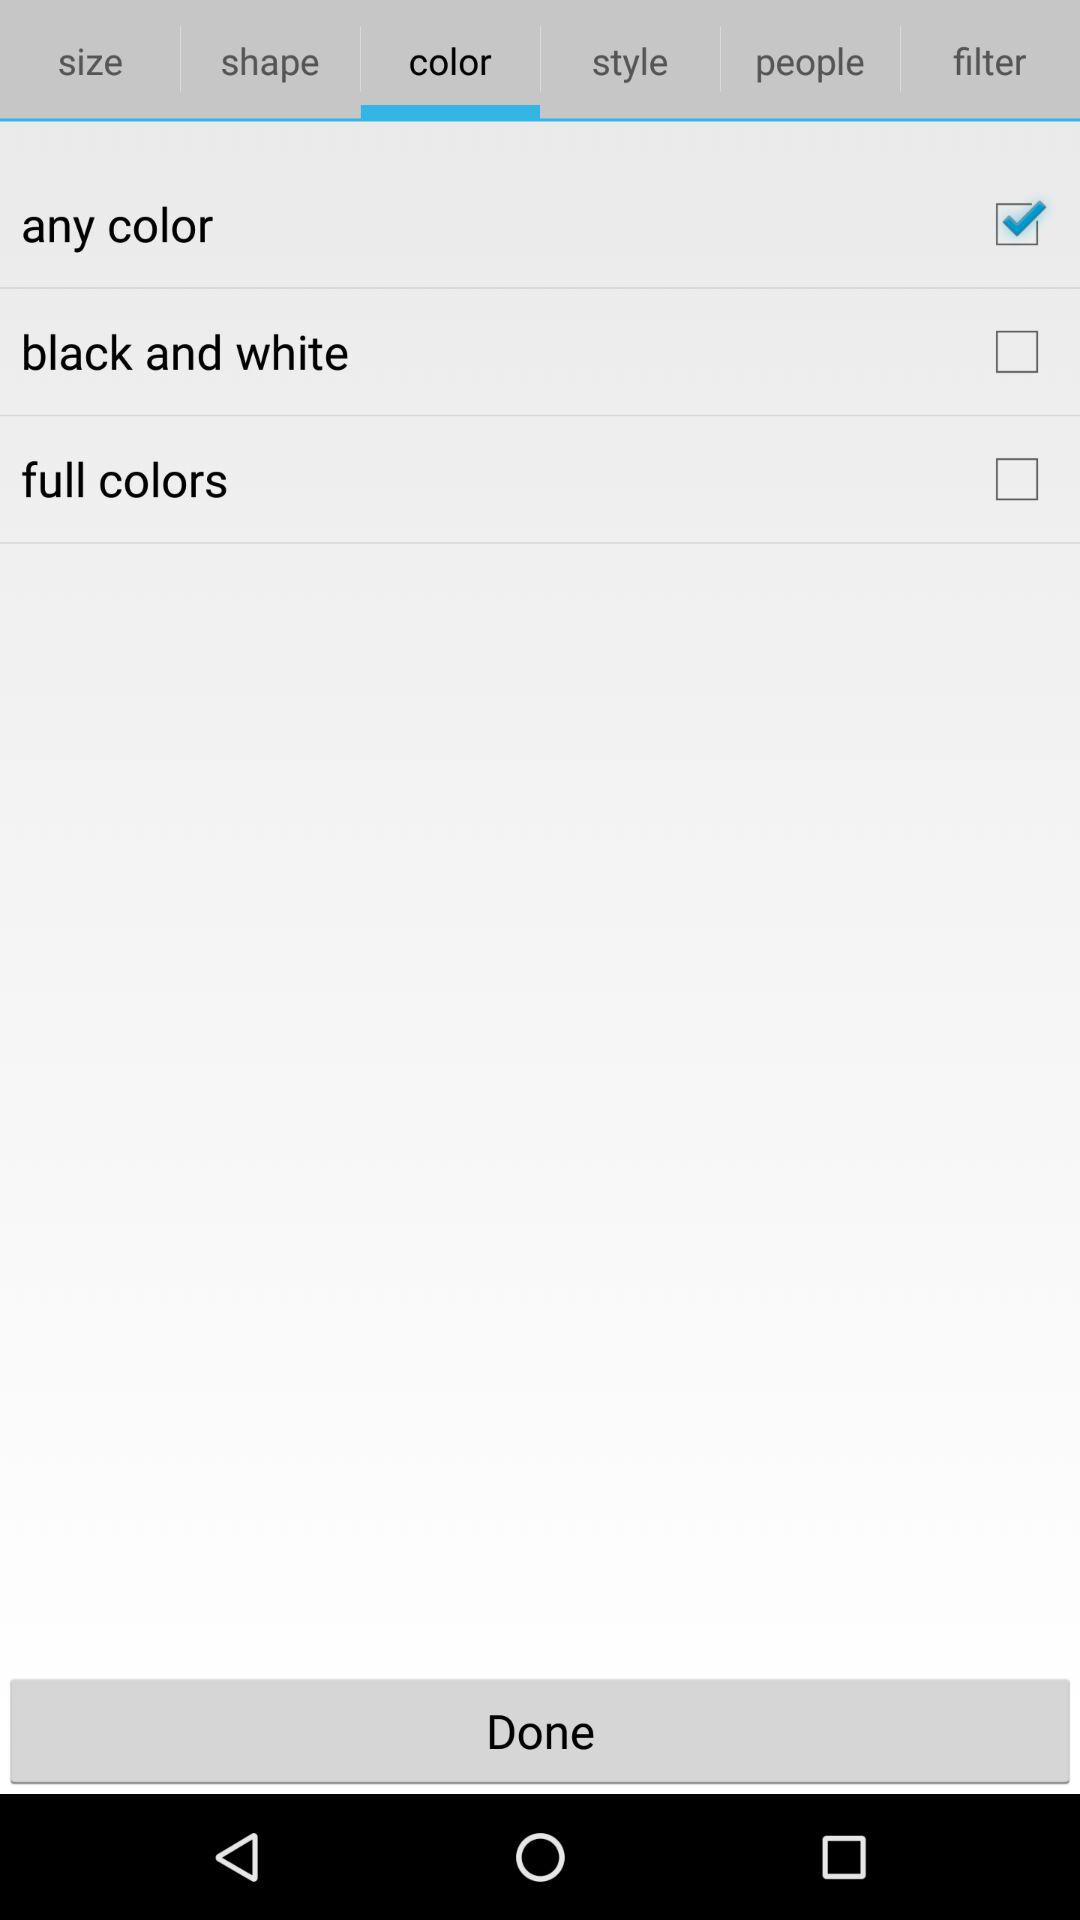How many color options are there?
Answer the question using a single word or phrase. 3 